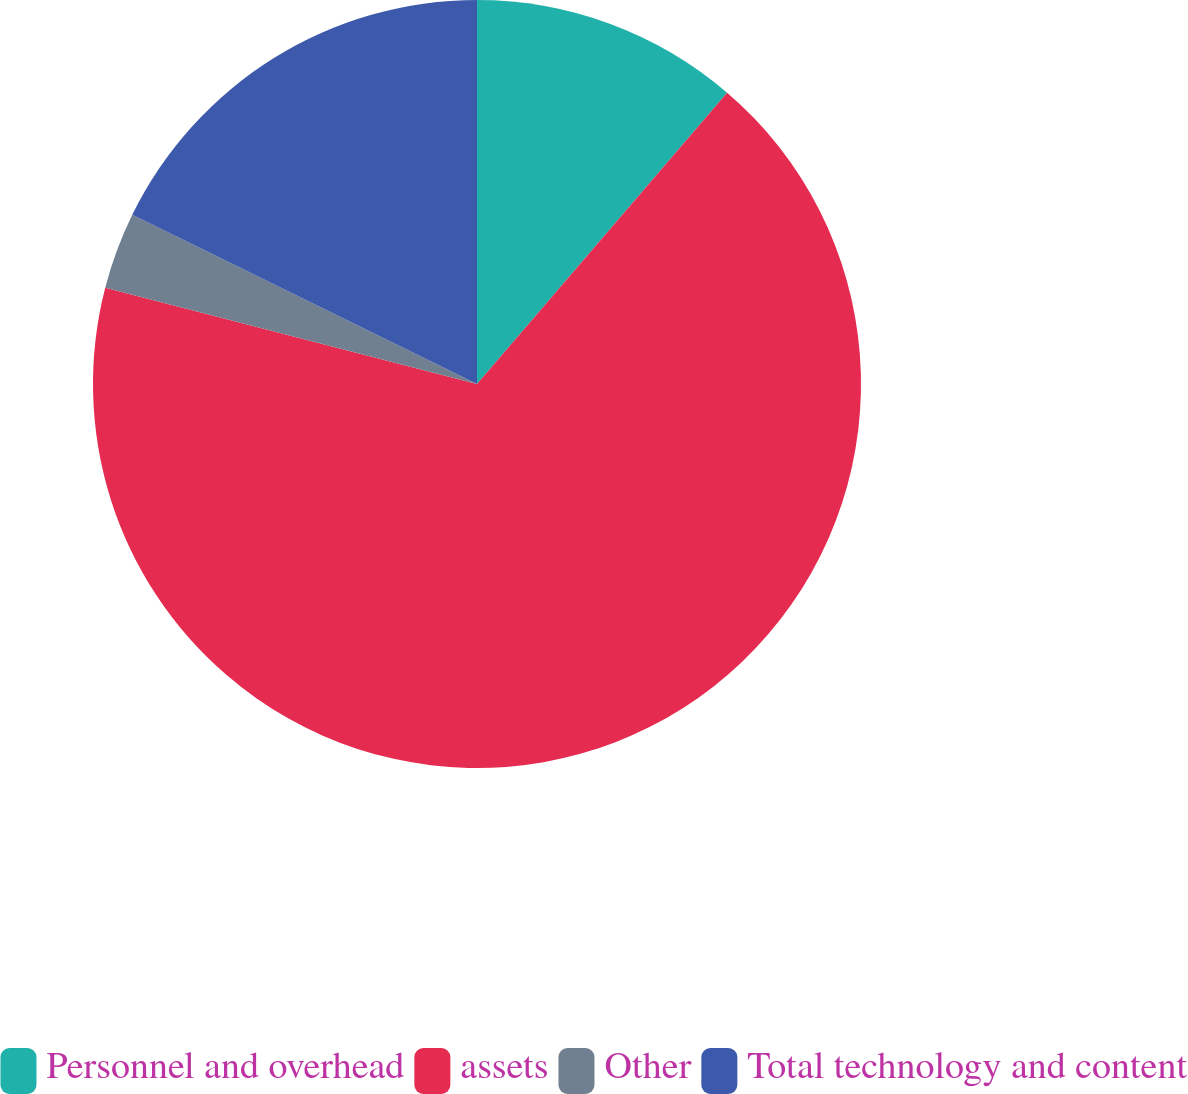Convert chart. <chart><loc_0><loc_0><loc_500><loc_500><pie_chart><fcel>Personnel and overhead<fcel>assets<fcel>Other<fcel>Total technology and content<nl><fcel>11.29%<fcel>67.74%<fcel>3.23%<fcel>17.74%<nl></chart> 